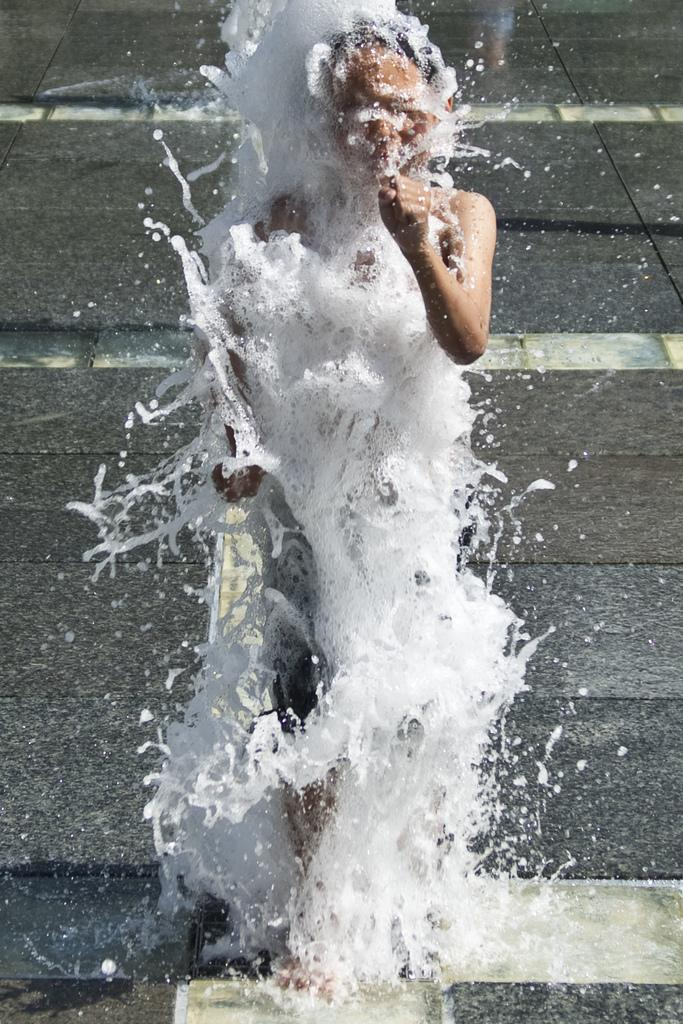What is the person in the image doing? The person in the image is standing in the water. What can be seen in the background of the image? There is a road visible in the background of the image. What type of bread is the person holding in the image? There is no bread or loaf present in the image. What type of insurance policy is being discussed in the image? There is no discussion of insurance policies in the image. What type of weapon is being used in the image? There is no weapon or war-related activity present in the image. 